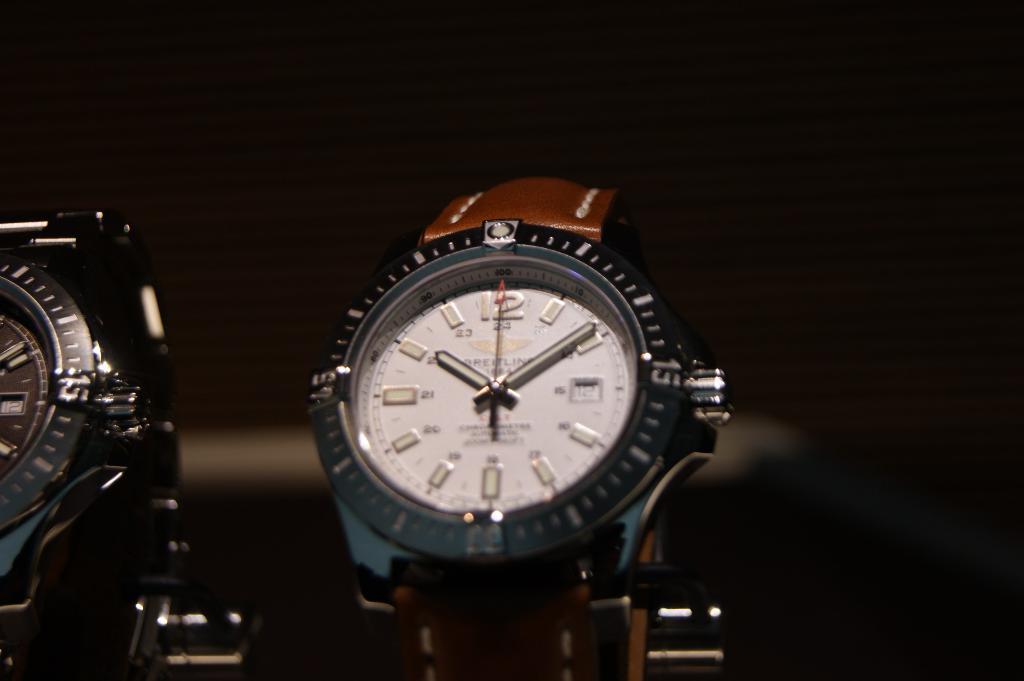What is the time on the watch?
Keep it short and to the point. 10:10. 